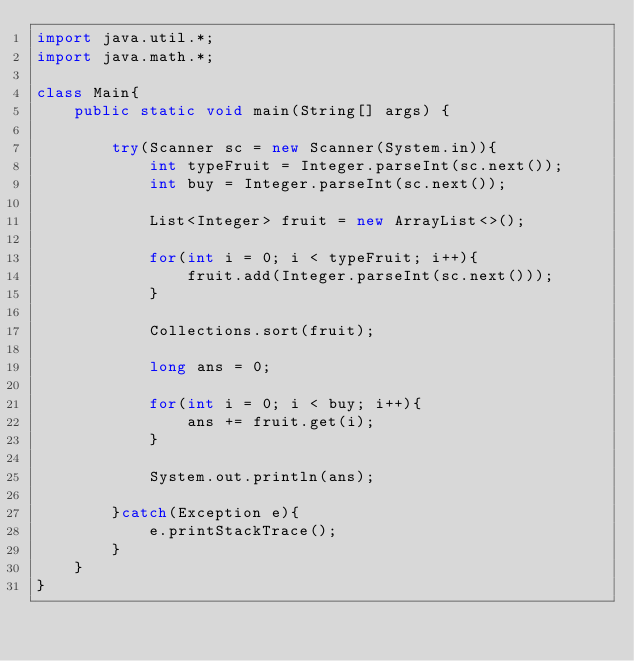Convert code to text. <code><loc_0><loc_0><loc_500><loc_500><_Java_>import java.util.*;
import java.math.*;
     
class Main{
    public static void main(String[] args) {
        
        try(Scanner sc = new Scanner(System.in)){
            int typeFruit = Integer.parseInt(sc.next());
            int buy = Integer.parseInt(sc.next());

            List<Integer> fruit = new ArrayList<>();

            for(int i = 0; i < typeFruit; i++){
                fruit.add(Integer.parseInt(sc.next()));
            }

            Collections.sort(fruit);

            long ans = 0;

            for(int i = 0; i < buy; i++){
                ans += fruit.get(i);
            }

            System.out.println(ans);

        }catch(Exception e){
            e.printStackTrace();
        }        
    }
}</code> 